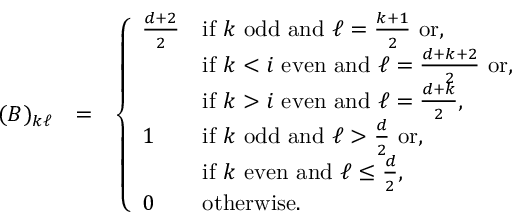Convert formula to latex. <formula><loc_0><loc_0><loc_500><loc_500>\begin{array} { r l r } { ( B ) _ { k \ell } } & { = } & { \left \{ \begin{array} { l l } { \frac { d + 2 } { 2 } } & { i f k o d d a n d \ell = \frac { k + 1 } { 2 } o r , } \\ & { i f k < i e v e n a n d \ell = \frac { d + k + 2 } { 2 } o r , } \\ & { i f k > i e v e n a n d \ell = \frac { d + k } { 2 } , } \\ { 1 } & { i f k o d d a n d \ell > \frac { d } { 2 } o r , } \\ & { i f k e v e n a n d \ell \leq \frac { d } { 2 } , } \\ { 0 } & { o t h e r w i s e . } \end{array} } \end{array}</formula> 